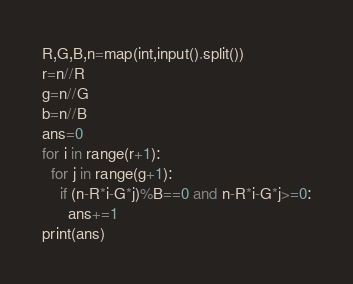<code> <loc_0><loc_0><loc_500><loc_500><_Python_>R,G,B,n=map(int,input().split())
r=n//R
g=n//G
b=n//B
ans=0
for i in range(r+1):
  for j in range(g+1):
    if (n-R*i-G*j)%B==0 and n-R*i-G*j>=0:
      ans+=1
print(ans)</code> 